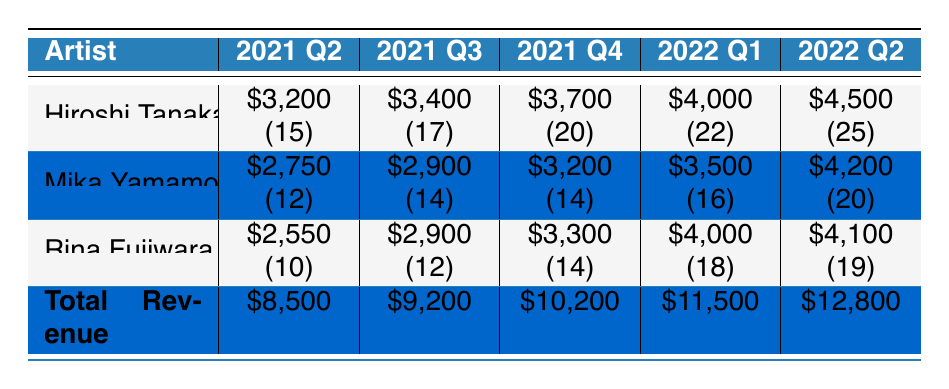What was the total revenue for fan art commissions in 2021 Q2? The table shows that the total revenue for 2021 Q2 is listed directly as \$8,500.
Answer: \$8,500 Which artist had the highest revenue in 2022 Q1? In 2022 Q1, the artist revenues are \$4,000 for Hiroshi Tanaka, \$3,500 for Mika Yamamoto, and \$4,000 for Rina Fujiwara. Both Hiroshi Tanaka and Rina Fujiwara have the highest revenue of \$4,000.
Answer: Hiroshi Tanaka and Rina Fujiwara What is the total revenue from all artists in 2022 Q2? The total revenue for 2022 Q2 is summed from the individual revenues: \$4,500 (Hiroshi Tanaka) + \$4,200 (Mika Yamamoto) + \$4,100 (Rina Fujiwara) = \$12,800. The table confirms this total revenue.
Answer: \$12,800 Did Mika Yamamoto's revenue increase in every quarter from 2021 Q2 to 2022 Q2? By comparing Mika Yamamoto's revenues across each quarter: 2021 Q2 - \$2,750, 2021 Q3 - \$2,900, 2021 Q4 - \$3,200, 2022 Q1 - \$3,500, and 2022 Q2 - \$4,200, we see that it consistently increased in each quarter.
Answer: Yes What was the average revenue per project for Rina Fujiwara in 2021 Q4? For 2021 Q4, Rina Fujiwara earned \$3,300 across 14 projects. To find the average revenue per project, divide the total revenue by the number of projects: \$3,300 / 14 = approximately \$235.71.
Answer: Approximately \$235.71 Which quarter had the lowest total revenue, and what was the amount? The table shows the total revenue across the quarters: 2021 Q2 - \$8,500, 2021 Q3 - \$9,200, 2021 Q4 - \$10,200, 2022 Q1 - \$11,500, and 2022 Q2 - \$12,800. The lowest total revenue is in 2021 Q2 with \$8,500.
Answer: 2021 Q2, \$8,500 What is the percentage increase in revenue from 2021 Q4 to 2022 Q2? The revenue in 2021 Q4 is \$10,200 and in 2022 Q2 is \$12,800. To calculate the percentage increase: (new value - old value) / old value * 100 = (\$12,800 - \$10,200) / \$10,200 * 100 = 25.49%.
Answer: Approximately 25.49% How many projects in total did Hiroshi Tanaka complete from 2021 Q2 to 2022 Q2? Summing up Hiroshi Tanaka's projects from each quarter: 15 (2021 Q2) + 17 (2021 Q3) + 20 (2021 Q4) + 22 (2022 Q1) + 25 (2022 Q2) equals a total of 99 projects completed.
Answer: 99 projects 